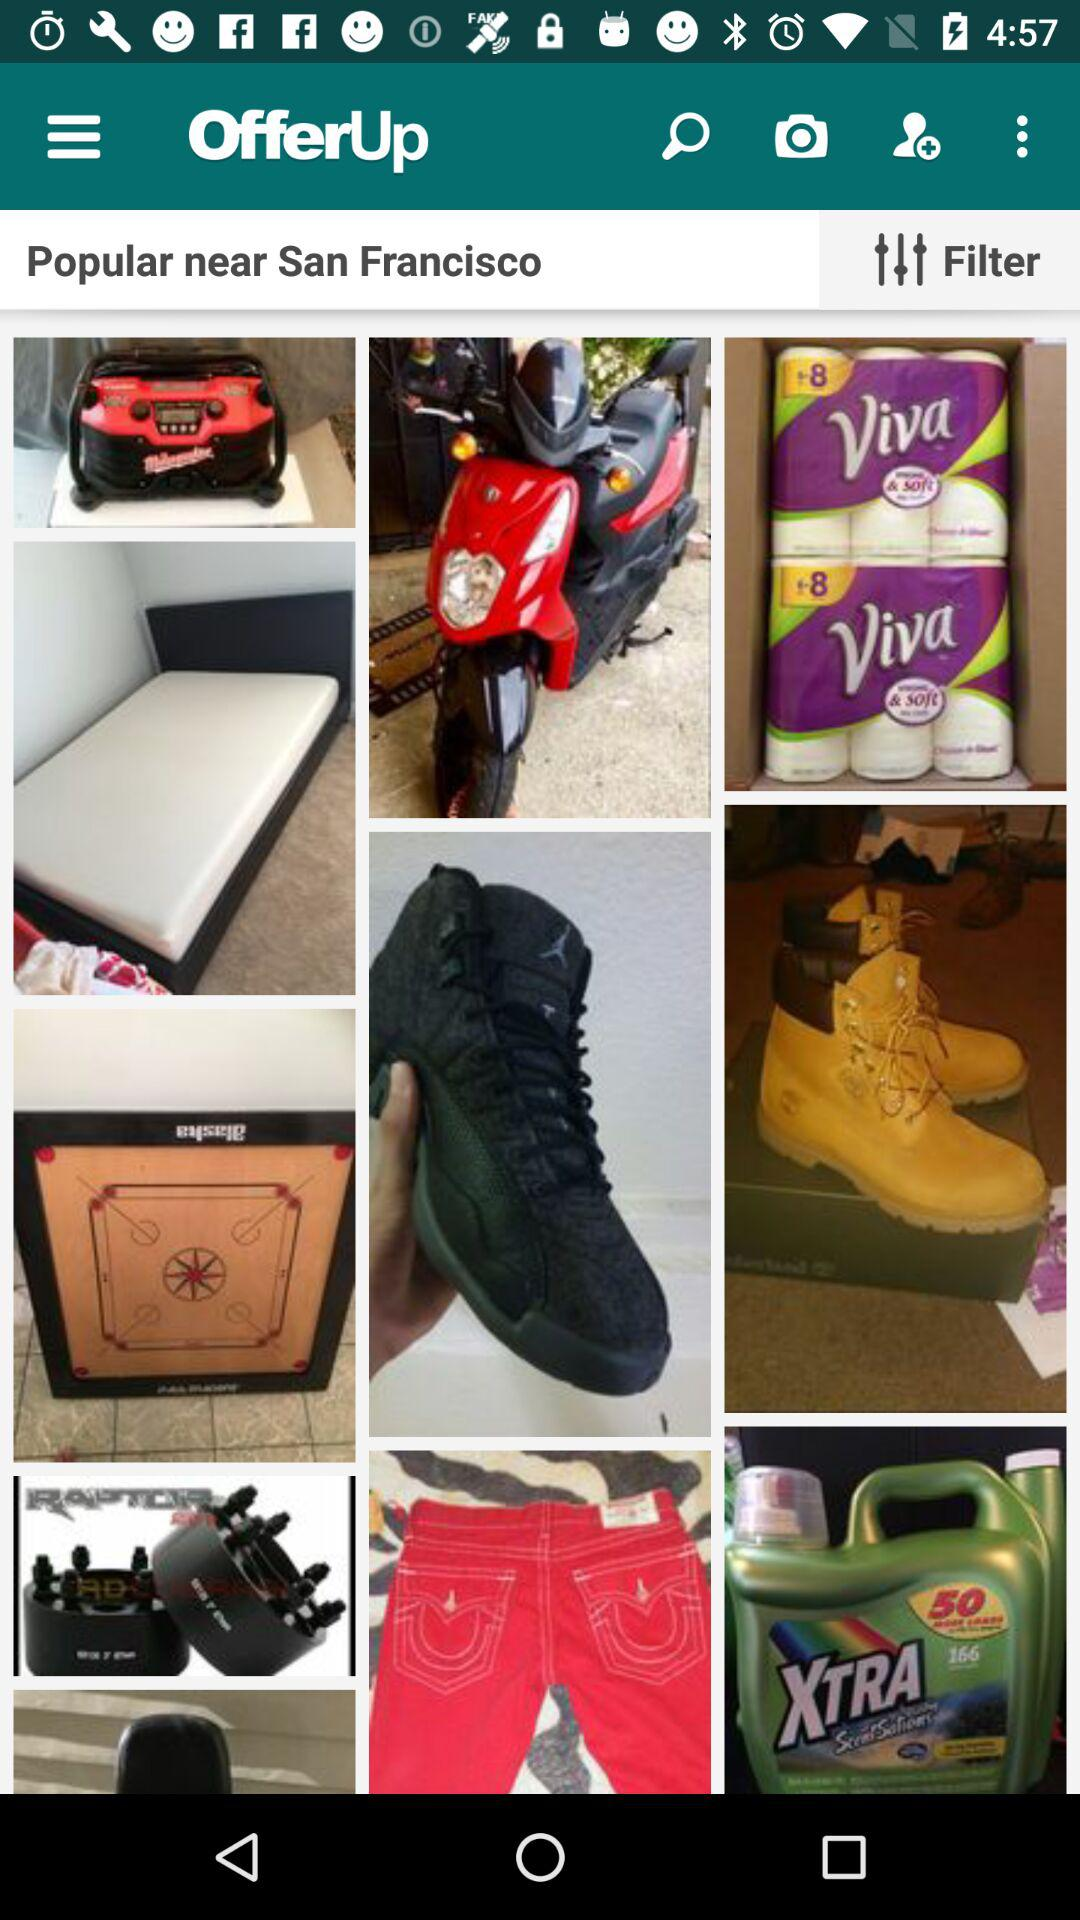What is the current location? The current location is San Francisco. 